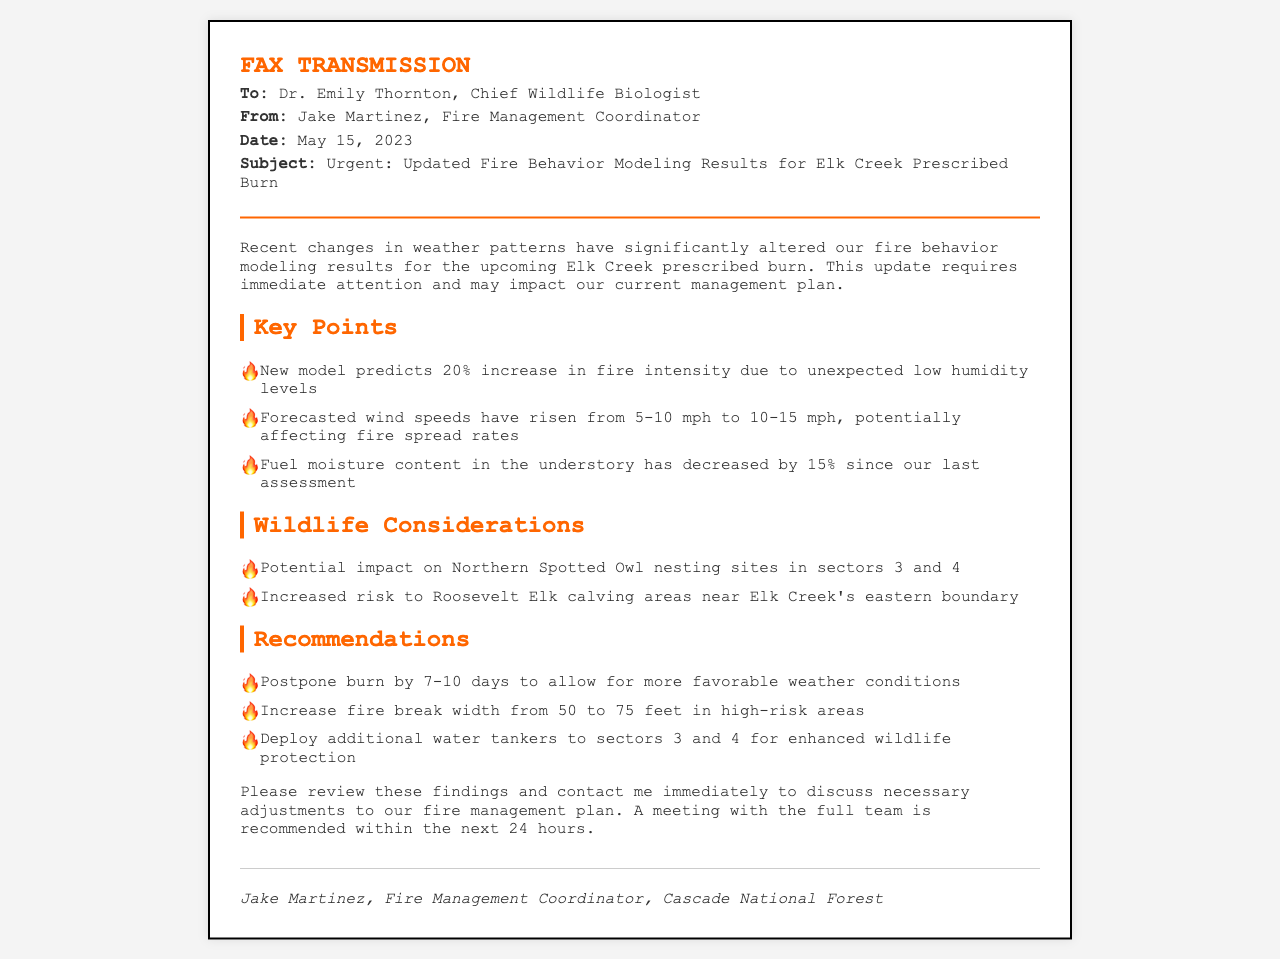what is the subject of the fax? The subject line details the main topic of the communication, which is urgent and relates to fire behavior modeling.
Answer: Urgent: Updated Fire Behavior Modeling Results for Elk Creek Prescribed Burn who is the sender of the fax? The sender's name is mentioned at the top of the document.
Answer: Jake Martinez when was the fax sent? The date of transmission is provided in the document's header.
Answer: May 15, 2023 what percentage increase in fire intensity is predicted? The document presents a specific numerical prediction regarding fire intensity.
Answer: 20% what has happened to fuel moisture content? The document states a measurable change in fuel moisture content since the last assessment.
Answer: Decreased by 15% which species' nesting sites are mentioned in the wildlife considerations? The wildlife concerns include specific species that may be affected by the burn.
Answer: Northern Spotted Owl how much should the fire break width be increased? The document provides a recommendation for changing the fire break width.
Answer: From 50 to 75 feet what is the recommended delay in days for the burn? A specific time frame is suggested in the recommendations section of the document.
Answer: 7-10 days where should additional water tankers be deployed? The document specifies locations for deploying additional resources.
Answer: Sectors 3 and 4 